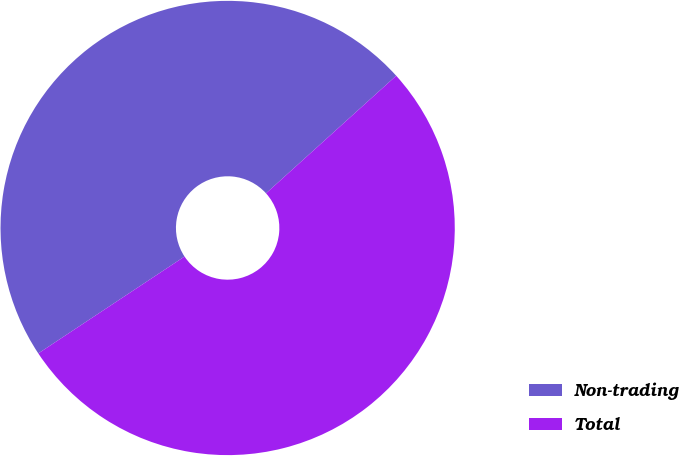Convert chart to OTSL. <chart><loc_0><loc_0><loc_500><loc_500><pie_chart><fcel>Non-trading<fcel>Total<nl><fcel>47.62%<fcel>52.38%<nl></chart> 